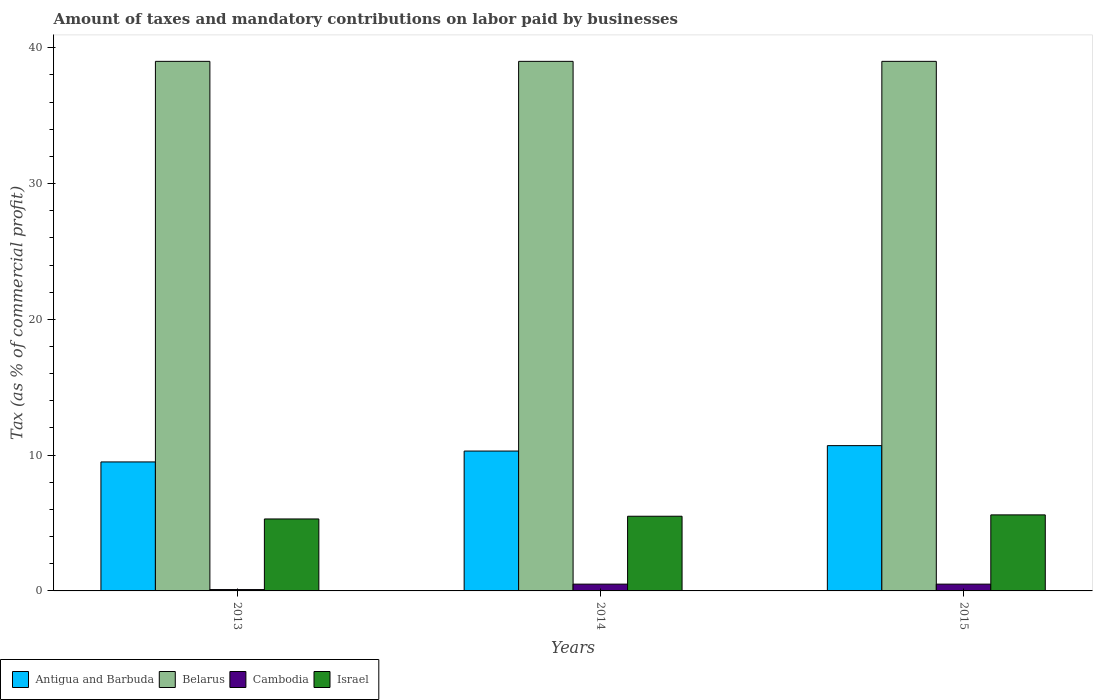How many different coloured bars are there?
Your answer should be compact. 4. What is the label of the 2nd group of bars from the left?
Provide a succinct answer. 2014. In how many cases, is the number of bars for a given year not equal to the number of legend labels?
Provide a succinct answer. 0. In which year was the percentage of taxes paid by businesses in Antigua and Barbuda maximum?
Your answer should be very brief. 2015. What is the total percentage of taxes paid by businesses in Israel in the graph?
Offer a very short reply. 16.4. What is the difference between the percentage of taxes paid by businesses in Israel in 2015 and the percentage of taxes paid by businesses in Cambodia in 2013?
Your response must be concise. 5.5. What is the average percentage of taxes paid by businesses in Antigua and Barbuda per year?
Give a very brief answer. 10.17. In the year 2015, what is the difference between the percentage of taxes paid by businesses in Cambodia and percentage of taxes paid by businesses in Israel?
Keep it short and to the point. -5.1. What is the ratio of the percentage of taxes paid by businesses in Belarus in 2014 to that in 2015?
Provide a short and direct response. 1. Is the percentage of taxes paid by businesses in Cambodia in 2014 less than that in 2015?
Provide a short and direct response. No. Is the difference between the percentage of taxes paid by businesses in Cambodia in 2013 and 2014 greater than the difference between the percentage of taxes paid by businesses in Israel in 2013 and 2014?
Ensure brevity in your answer.  No. What is the difference between the highest and the second highest percentage of taxes paid by businesses in Antigua and Barbuda?
Provide a succinct answer. 0.4. What is the difference between the highest and the lowest percentage of taxes paid by businesses in Antigua and Barbuda?
Ensure brevity in your answer.  1.2. Is the sum of the percentage of taxes paid by businesses in Antigua and Barbuda in 2013 and 2014 greater than the maximum percentage of taxes paid by businesses in Belarus across all years?
Provide a succinct answer. No. What does the 2nd bar from the left in 2013 represents?
Keep it short and to the point. Belarus. What does the 2nd bar from the right in 2013 represents?
Make the answer very short. Cambodia. Is it the case that in every year, the sum of the percentage of taxes paid by businesses in Antigua and Barbuda and percentage of taxes paid by businesses in Cambodia is greater than the percentage of taxes paid by businesses in Israel?
Provide a succinct answer. Yes. How many bars are there?
Provide a succinct answer. 12. Are all the bars in the graph horizontal?
Your answer should be very brief. No. How many years are there in the graph?
Your answer should be compact. 3. Are the values on the major ticks of Y-axis written in scientific E-notation?
Provide a short and direct response. No. Does the graph contain any zero values?
Your answer should be compact. No. Does the graph contain grids?
Give a very brief answer. No. How many legend labels are there?
Make the answer very short. 4. How are the legend labels stacked?
Provide a succinct answer. Horizontal. What is the title of the graph?
Offer a terse response. Amount of taxes and mandatory contributions on labor paid by businesses. Does "Grenada" appear as one of the legend labels in the graph?
Your answer should be very brief. No. What is the label or title of the Y-axis?
Provide a short and direct response. Tax (as % of commercial profit). What is the Tax (as % of commercial profit) in Cambodia in 2013?
Provide a succinct answer. 0.1. What is the Tax (as % of commercial profit) in Belarus in 2014?
Offer a terse response. 39. What is the Tax (as % of commercial profit) in Cambodia in 2014?
Give a very brief answer. 0.5. What is the Tax (as % of commercial profit) in Antigua and Barbuda in 2015?
Provide a succinct answer. 10.7. What is the Tax (as % of commercial profit) of Belarus in 2015?
Offer a very short reply. 39. What is the Tax (as % of commercial profit) in Cambodia in 2015?
Provide a short and direct response. 0.5. What is the Tax (as % of commercial profit) in Israel in 2015?
Offer a terse response. 5.6. Across all years, what is the maximum Tax (as % of commercial profit) of Belarus?
Offer a very short reply. 39. Across all years, what is the maximum Tax (as % of commercial profit) of Israel?
Offer a terse response. 5.6. Across all years, what is the minimum Tax (as % of commercial profit) of Antigua and Barbuda?
Make the answer very short. 9.5. Across all years, what is the minimum Tax (as % of commercial profit) of Cambodia?
Your answer should be compact. 0.1. Across all years, what is the minimum Tax (as % of commercial profit) of Israel?
Keep it short and to the point. 5.3. What is the total Tax (as % of commercial profit) in Antigua and Barbuda in the graph?
Make the answer very short. 30.5. What is the total Tax (as % of commercial profit) of Belarus in the graph?
Make the answer very short. 117. What is the difference between the Tax (as % of commercial profit) in Antigua and Barbuda in 2013 and that in 2014?
Give a very brief answer. -0.8. What is the difference between the Tax (as % of commercial profit) in Belarus in 2013 and that in 2014?
Provide a short and direct response. 0. What is the difference between the Tax (as % of commercial profit) in Israel in 2013 and that in 2014?
Make the answer very short. -0.2. What is the difference between the Tax (as % of commercial profit) of Cambodia in 2014 and that in 2015?
Your answer should be compact. 0. What is the difference between the Tax (as % of commercial profit) of Israel in 2014 and that in 2015?
Your answer should be very brief. -0.1. What is the difference between the Tax (as % of commercial profit) in Antigua and Barbuda in 2013 and the Tax (as % of commercial profit) in Belarus in 2014?
Your response must be concise. -29.5. What is the difference between the Tax (as % of commercial profit) in Antigua and Barbuda in 2013 and the Tax (as % of commercial profit) in Israel in 2014?
Your answer should be compact. 4. What is the difference between the Tax (as % of commercial profit) of Belarus in 2013 and the Tax (as % of commercial profit) of Cambodia in 2014?
Offer a very short reply. 38.5. What is the difference between the Tax (as % of commercial profit) of Belarus in 2013 and the Tax (as % of commercial profit) of Israel in 2014?
Offer a very short reply. 33.5. What is the difference between the Tax (as % of commercial profit) in Antigua and Barbuda in 2013 and the Tax (as % of commercial profit) in Belarus in 2015?
Provide a succinct answer. -29.5. What is the difference between the Tax (as % of commercial profit) of Antigua and Barbuda in 2013 and the Tax (as % of commercial profit) of Israel in 2015?
Ensure brevity in your answer.  3.9. What is the difference between the Tax (as % of commercial profit) of Belarus in 2013 and the Tax (as % of commercial profit) of Cambodia in 2015?
Provide a short and direct response. 38.5. What is the difference between the Tax (as % of commercial profit) of Belarus in 2013 and the Tax (as % of commercial profit) of Israel in 2015?
Provide a short and direct response. 33.4. What is the difference between the Tax (as % of commercial profit) in Antigua and Barbuda in 2014 and the Tax (as % of commercial profit) in Belarus in 2015?
Ensure brevity in your answer.  -28.7. What is the difference between the Tax (as % of commercial profit) of Antigua and Barbuda in 2014 and the Tax (as % of commercial profit) of Cambodia in 2015?
Keep it short and to the point. 9.8. What is the difference between the Tax (as % of commercial profit) of Belarus in 2014 and the Tax (as % of commercial profit) of Cambodia in 2015?
Ensure brevity in your answer.  38.5. What is the difference between the Tax (as % of commercial profit) in Belarus in 2014 and the Tax (as % of commercial profit) in Israel in 2015?
Make the answer very short. 33.4. What is the average Tax (as % of commercial profit) of Antigua and Barbuda per year?
Your answer should be very brief. 10.17. What is the average Tax (as % of commercial profit) of Belarus per year?
Provide a succinct answer. 39. What is the average Tax (as % of commercial profit) in Cambodia per year?
Offer a terse response. 0.37. What is the average Tax (as % of commercial profit) in Israel per year?
Provide a succinct answer. 5.47. In the year 2013, what is the difference between the Tax (as % of commercial profit) in Antigua and Barbuda and Tax (as % of commercial profit) in Belarus?
Provide a succinct answer. -29.5. In the year 2013, what is the difference between the Tax (as % of commercial profit) of Belarus and Tax (as % of commercial profit) of Cambodia?
Make the answer very short. 38.9. In the year 2013, what is the difference between the Tax (as % of commercial profit) in Belarus and Tax (as % of commercial profit) in Israel?
Keep it short and to the point. 33.7. In the year 2013, what is the difference between the Tax (as % of commercial profit) of Cambodia and Tax (as % of commercial profit) of Israel?
Offer a terse response. -5.2. In the year 2014, what is the difference between the Tax (as % of commercial profit) of Antigua and Barbuda and Tax (as % of commercial profit) of Belarus?
Offer a very short reply. -28.7. In the year 2014, what is the difference between the Tax (as % of commercial profit) in Antigua and Barbuda and Tax (as % of commercial profit) in Cambodia?
Ensure brevity in your answer.  9.8. In the year 2014, what is the difference between the Tax (as % of commercial profit) in Belarus and Tax (as % of commercial profit) in Cambodia?
Ensure brevity in your answer.  38.5. In the year 2014, what is the difference between the Tax (as % of commercial profit) in Belarus and Tax (as % of commercial profit) in Israel?
Provide a succinct answer. 33.5. In the year 2015, what is the difference between the Tax (as % of commercial profit) in Antigua and Barbuda and Tax (as % of commercial profit) in Belarus?
Ensure brevity in your answer.  -28.3. In the year 2015, what is the difference between the Tax (as % of commercial profit) in Antigua and Barbuda and Tax (as % of commercial profit) in Cambodia?
Ensure brevity in your answer.  10.2. In the year 2015, what is the difference between the Tax (as % of commercial profit) of Belarus and Tax (as % of commercial profit) of Cambodia?
Keep it short and to the point. 38.5. In the year 2015, what is the difference between the Tax (as % of commercial profit) in Belarus and Tax (as % of commercial profit) in Israel?
Offer a very short reply. 33.4. What is the ratio of the Tax (as % of commercial profit) of Antigua and Barbuda in 2013 to that in 2014?
Offer a terse response. 0.92. What is the ratio of the Tax (as % of commercial profit) in Belarus in 2013 to that in 2014?
Offer a terse response. 1. What is the ratio of the Tax (as % of commercial profit) in Cambodia in 2013 to that in 2014?
Ensure brevity in your answer.  0.2. What is the ratio of the Tax (as % of commercial profit) of Israel in 2013 to that in 2014?
Make the answer very short. 0.96. What is the ratio of the Tax (as % of commercial profit) in Antigua and Barbuda in 2013 to that in 2015?
Keep it short and to the point. 0.89. What is the ratio of the Tax (as % of commercial profit) in Israel in 2013 to that in 2015?
Ensure brevity in your answer.  0.95. What is the ratio of the Tax (as % of commercial profit) in Antigua and Barbuda in 2014 to that in 2015?
Your response must be concise. 0.96. What is the ratio of the Tax (as % of commercial profit) in Cambodia in 2014 to that in 2015?
Provide a succinct answer. 1. What is the ratio of the Tax (as % of commercial profit) in Israel in 2014 to that in 2015?
Ensure brevity in your answer.  0.98. What is the difference between the highest and the second highest Tax (as % of commercial profit) of Antigua and Barbuda?
Keep it short and to the point. 0.4. What is the difference between the highest and the second highest Tax (as % of commercial profit) in Belarus?
Provide a succinct answer. 0. What is the difference between the highest and the lowest Tax (as % of commercial profit) of Antigua and Barbuda?
Make the answer very short. 1.2. What is the difference between the highest and the lowest Tax (as % of commercial profit) in Belarus?
Keep it short and to the point. 0. 